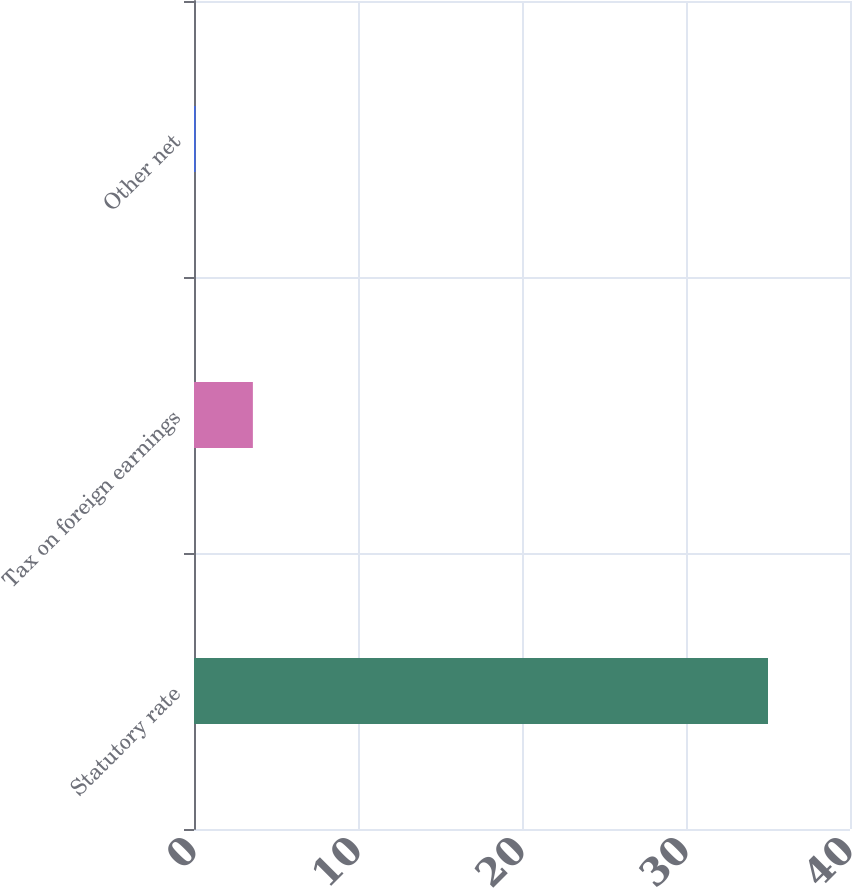Convert chart. <chart><loc_0><loc_0><loc_500><loc_500><bar_chart><fcel>Statutory rate<fcel>Tax on foreign earnings<fcel>Other net<nl><fcel>35<fcel>3.59<fcel>0.1<nl></chart> 